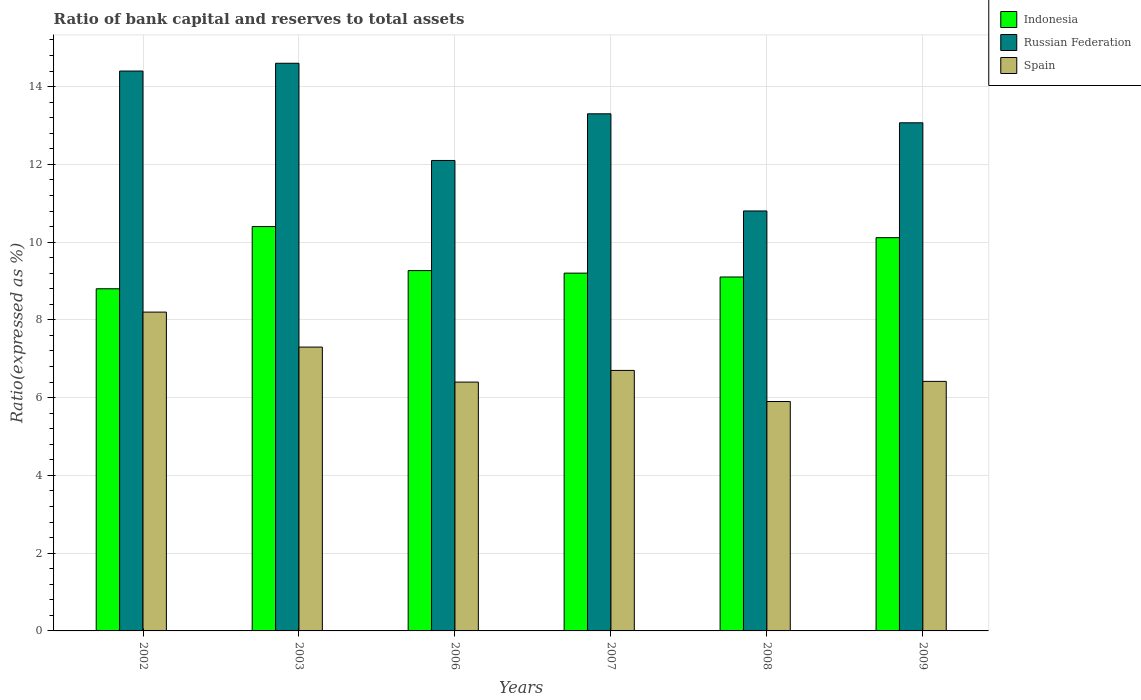How many different coloured bars are there?
Your answer should be compact. 3. How many groups of bars are there?
Provide a short and direct response. 6. How many bars are there on the 3rd tick from the right?
Make the answer very short. 3. What is the label of the 3rd group of bars from the left?
Provide a succinct answer. 2006. What is the ratio of bank capital and reserves to total assets in Indonesia in 2003?
Make the answer very short. 10.4. In which year was the ratio of bank capital and reserves to total assets in Spain maximum?
Ensure brevity in your answer.  2002. What is the total ratio of bank capital and reserves to total assets in Spain in the graph?
Keep it short and to the point. 40.92. What is the difference between the ratio of bank capital and reserves to total assets in Spain in 2002 and that in 2009?
Your response must be concise. 1.78. What is the difference between the ratio of bank capital and reserves to total assets in Spain in 2009 and the ratio of bank capital and reserves to total assets in Russian Federation in 2002?
Your answer should be very brief. -7.98. What is the average ratio of bank capital and reserves to total assets in Spain per year?
Make the answer very short. 6.82. In the year 2007, what is the difference between the ratio of bank capital and reserves to total assets in Indonesia and ratio of bank capital and reserves to total assets in Spain?
Ensure brevity in your answer.  2.5. What is the ratio of the ratio of bank capital and reserves to total assets in Spain in 2002 to that in 2007?
Make the answer very short. 1.22. What is the difference between the highest and the second highest ratio of bank capital and reserves to total assets in Russian Federation?
Your answer should be very brief. 0.2. What is the difference between the highest and the lowest ratio of bank capital and reserves to total assets in Spain?
Ensure brevity in your answer.  2.3. Is the sum of the ratio of bank capital and reserves to total assets in Indonesia in 2002 and 2009 greater than the maximum ratio of bank capital and reserves to total assets in Spain across all years?
Keep it short and to the point. Yes. What does the 3rd bar from the left in 2002 represents?
Your answer should be compact. Spain. What does the 1st bar from the right in 2008 represents?
Provide a short and direct response. Spain. Are all the bars in the graph horizontal?
Keep it short and to the point. No. How many years are there in the graph?
Provide a succinct answer. 6. Does the graph contain grids?
Ensure brevity in your answer.  Yes. How are the legend labels stacked?
Give a very brief answer. Vertical. What is the title of the graph?
Your response must be concise. Ratio of bank capital and reserves to total assets. What is the label or title of the Y-axis?
Keep it short and to the point. Ratio(expressed as %). What is the Ratio(expressed as %) in Indonesia in 2002?
Your response must be concise. 8.8. What is the Ratio(expressed as %) in Spain in 2002?
Your answer should be very brief. 8.2. What is the Ratio(expressed as %) in Indonesia in 2006?
Ensure brevity in your answer.  9.27. What is the Ratio(expressed as %) of Russian Federation in 2006?
Your response must be concise. 12.1. What is the Ratio(expressed as %) of Indonesia in 2007?
Give a very brief answer. 9.2. What is the Ratio(expressed as %) of Indonesia in 2008?
Provide a short and direct response. 9.1. What is the Ratio(expressed as %) in Russian Federation in 2008?
Provide a succinct answer. 10.8. What is the Ratio(expressed as %) in Spain in 2008?
Your answer should be compact. 5.9. What is the Ratio(expressed as %) of Indonesia in 2009?
Your response must be concise. 10.11. What is the Ratio(expressed as %) in Russian Federation in 2009?
Provide a succinct answer. 13.07. What is the Ratio(expressed as %) of Spain in 2009?
Keep it short and to the point. 6.42. Across all years, what is the maximum Ratio(expressed as %) in Russian Federation?
Make the answer very short. 14.6. Across all years, what is the minimum Ratio(expressed as %) in Indonesia?
Provide a succinct answer. 8.8. Across all years, what is the minimum Ratio(expressed as %) in Russian Federation?
Your answer should be very brief. 10.8. What is the total Ratio(expressed as %) of Indonesia in the graph?
Give a very brief answer. 56.89. What is the total Ratio(expressed as %) of Russian Federation in the graph?
Make the answer very short. 78.27. What is the total Ratio(expressed as %) in Spain in the graph?
Your answer should be compact. 40.92. What is the difference between the Ratio(expressed as %) of Indonesia in 2002 and that in 2003?
Your answer should be very brief. -1.6. What is the difference between the Ratio(expressed as %) in Russian Federation in 2002 and that in 2003?
Your response must be concise. -0.2. What is the difference between the Ratio(expressed as %) in Spain in 2002 and that in 2003?
Provide a succinct answer. 0.9. What is the difference between the Ratio(expressed as %) of Indonesia in 2002 and that in 2006?
Provide a succinct answer. -0.47. What is the difference between the Ratio(expressed as %) of Russian Federation in 2002 and that in 2006?
Ensure brevity in your answer.  2.3. What is the difference between the Ratio(expressed as %) in Spain in 2002 and that in 2006?
Ensure brevity in your answer.  1.8. What is the difference between the Ratio(expressed as %) of Indonesia in 2002 and that in 2007?
Keep it short and to the point. -0.4. What is the difference between the Ratio(expressed as %) in Russian Federation in 2002 and that in 2007?
Give a very brief answer. 1.1. What is the difference between the Ratio(expressed as %) in Indonesia in 2002 and that in 2008?
Your response must be concise. -0.3. What is the difference between the Ratio(expressed as %) in Russian Federation in 2002 and that in 2008?
Give a very brief answer. 3.6. What is the difference between the Ratio(expressed as %) of Spain in 2002 and that in 2008?
Provide a succinct answer. 2.3. What is the difference between the Ratio(expressed as %) in Indonesia in 2002 and that in 2009?
Your response must be concise. -1.31. What is the difference between the Ratio(expressed as %) of Russian Federation in 2002 and that in 2009?
Provide a succinct answer. 1.33. What is the difference between the Ratio(expressed as %) in Spain in 2002 and that in 2009?
Offer a terse response. 1.78. What is the difference between the Ratio(expressed as %) of Indonesia in 2003 and that in 2006?
Ensure brevity in your answer.  1.13. What is the difference between the Ratio(expressed as %) of Russian Federation in 2003 and that in 2006?
Provide a succinct answer. 2.5. What is the difference between the Ratio(expressed as %) of Spain in 2003 and that in 2006?
Provide a succinct answer. 0.9. What is the difference between the Ratio(expressed as %) of Indonesia in 2003 and that in 2007?
Provide a succinct answer. 1.2. What is the difference between the Ratio(expressed as %) of Indonesia in 2003 and that in 2008?
Make the answer very short. 1.3. What is the difference between the Ratio(expressed as %) of Russian Federation in 2003 and that in 2008?
Provide a short and direct response. 3.8. What is the difference between the Ratio(expressed as %) in Spain in 2003 and that in 2008?
Offer a terse response. 1.4. What is the difference between the Ratio(expressed as %) of Indonesia in 2003 and that in 2009?
Your response must be concise. 0.29. What is the difference between the Ratio(expressed as %) of Russian Federation in 2003 and that in 2009?
Provide a short and direct response. 1.53. What is the difference between the Ratio(expressed as %) in Spain in 2003 and that in 2009?
Offer a very short reply. 0.88. What is the difference between the Ratio(expressed as %) of Indonesia in 2006 and that in 2007?
Provide a short and direct response. 0.07. What is the difference between the Ratio(expressed as %) of Spain in 2006 and that in 2007?
Keep it short and to the point. -0.3. What is the difference between the Ratio(expressed as %) in Indonesia in 2006 and that in 2008?
Your answer should be very brief. 0.16. What is the difference between the Ratio(expressed as %) of Russian Federation in 2006 and that in 2008?
Make the answer very short. 1.3. What is the difference between the Ratio(expressed as %) of Spain in 2006 and that in 2008?
Offer a terse response. 0.5. What is the difference between the Ratio(expressed as %) of Indonesia in 2006 and that in 2009?
Give a very brief answer. -0.85. What is the difference between the Ratio(expressed as %) in Russian Federation in 2006 and that in 2009?
Make the answer very short. -0.97. What is the difference between the Ratio(expressed as %) in Spain in 2006 and that in 2009?
Your answer should be compact. -0.02. What is the difference between the Ratio(expressed as %) of Indonesia in 2007 and that in 2008?
Make the answer very short. 0.1. What is the difference between the Ratio(expressed as %) of Russian Federation in 2007 and that in 2008?
Make the answer very short. 2.5. What is the difference between the Ratio(expressed as %) of Spain in 2007 and that in 2008?
Make the answer very short. 0.8. What is the difference between the Ratio(expressed as %) of Indonesia in 2007 and that in 2009?
Provide a succinct answer. -0.91. What is the difference between the Ratio(expressed as %) in Russian Federation in 2007 and that in 2009?
Your answer should be compact. 0.23. What is the difference between the Ratio(expressed as %) of Spain in 2007 and that in 2009?
Offer a very short reply. 0.28. What is the difference between the Ratio(expressed as %) of Indonesia in 2008 and that in 2009?
Make the answer very short. -1.01. What is the difference between the Ratio(expressed as %) in Russian Federation in 2008 and that in 2009?
Ensure brevity in your answer.  -2.27. What is the difference between the Ratio(expressed as %) of Spain in 2008 and that in 2009?
Keep it short and to the point. -0.52. What is the difference between the Ratio(expressed as %) of Indonesia in 2002 and the Ratio(expressed as %) of Russian Federation in 2003?
Keep it short and to the point. -5.8. What is the difference between the Ratio(expressed as %) in Indonesia in 2002 and the Ratio(expressed as %) in Spain in 2003?
Offer a very short reply. 1.5. What is the difference between the Ratio(expressed as %) in Russian Federation in 2002 and the Ratio(expressed as %) in Spain in 2003?
Ensure brevity in your answer.  7.1. What is the difference between the Ratio(expressed as %) in Indonesia in 2002 and the Ratio(expressed as %) in Russian Federation in 2007?
Your response must be concise. -4.5. What is the difference between the Ratio(expressed as %) of Indonesia in 2002 and the Ratio(expressed as %) of Russian Federation in 2008?
Keep it short and to the point. -2. What is the difference between the Ratio(expressed as %) of Indonesia in 2002 and the Ratio(expressed as %) of Russian Federation in 2009?
Offer a very short reply. -4.27. What is the difference between the Ratio(expressed as %) in Indonesia in 2002 and the Ratio(expressed as %) in Spain in 2009?
Offer a terse response. 2.38. What is the difference between the Ratio(expressed as %) in Russian Federation in 2002 and the Ratio(expressed as %) in Spain in 2009?
Make the answer very short. 7.98. What is the difference between the Ratio(expressed as %) in Russian Federation in 2003 and the Ratio(expressed as %) in Spain in 2006?
Your answer should be compact. 8.2. What is the difference between the Ratio(expressed as %) of Indonesia in 2003 and the Ratio(expressed as %) of Russian Federation in 2007?
Your answer should be compact. -2.9. What is the difference between the Ratio(expressed as %) in Indonesia in 2003 and the Ratio(expressed as %) in Russian Federation in 2008?
Provide a short and direct response. -0.4. What is the difference between the Ratio(expressed as %) of Russian Federation in 2003 and the Ratio(expressed as %) of Spain in 2008?
Give a very brief answer. 8.7. What is the difference between the Ratio(expressed as %) of Indonesia in 2003 and the Ratio(expressed as %) of Russian Federation in 2009?
Make the answer very short. -2.67. What is the difference between the Ratio(expressed as %) in Indonesia in 2003 and the Ratio(expressed as %) in Spain in 2009?
Provide a short and direct response. 3.98. What is the difference between the Ratio(expressed as %) in Russian Federation in 2003 and the Ratio(expressed as %) in Spain in 2009?
Your answer should be compact. 8.18. What is the difference between the Ratio(expressed as %) of Indonesia in 2006 and the Ratio(expressed as %) of Russian Federation in 2007?
Ensure brevity in your answer.  -4.03. What is the difference between the Ratio(expressed as %) of Indonesia in 2006 and the Ratio(expressed as %) of Spain in 2007?
Offer a very short reply. 2.57. What is the difference between the Ratio(expressed as %) of Russian Federation in 2006 and the Ratio(expressed as %) of Spain in 2007?
Make the answer very short. 5.4. What is the difference between the Ratio(expressed as %) of Indonesia in 2006 and the Ratio(expressed as %) of Russian Federation in 2008?
Make the answer very short. -1.53. What is the difference between the Ratio(expressed as %) in Indonesia in 2006 and the Ratio(expressed as %) in Spain in 2008?
Ensure brevity in your answer.  3.37. What is the difference between the Ratio(expressed as %) in Russian Federation in 2006 and the Ratio(expressed as %) in Spain in 2008?
Keep it short and to the point. 6.2. What is the difference between the Ratio(expressed as %) in Indonesia in 2006 and the Ratio(expressed as %) in Russian Federation in 2009?
Ensure brevity in your answer.  -3.8. What is the difference between the Ratio(expressed as %) in Indonesia in 2006 and the Ratio(expressed as %) in Spain in 2009?
Your answer should be very brief. 2.85. What is the difference between the Ratio(expressed as %) in Russian Federation in 2006 and the Ratio(expressed as %) in Spain in 2009?
Make the answer very short. 5.68. What is the difference between the Ratio(expressed as %) in Indonesia in 2007 and the Ratio(expressed as %) in Russian Federation in 2008?
Your answer should be very brief. -1.6. What is the difference between the Ratio(expressed as %) of Indonesia in 2007 and the Ratio(expressed as %) of Spain in 2008?
Your answer should be compact. 3.3. What is the difference between the Ratio(expressed as %) of Russian Federation in 2007 and the Ratio(expressed as %) of Spain in 2008?
Your answer should be very brief. 7.4. What is the difference between the Ratio(expressed as %) in Indonesia in 2007 and the Ratio(expressed as %) in Russian Federation in 2009?
Give a very brief answer. -3.87. What is the difference between the Ratio(expressed as %) of Indonesia in 2007 and the Ratio(expressed as %) of Spain in 2009?
Your answer should be compact. 2.78. What is the difference between the Ratio(expressed as %) of Russian Federation in 2007 and the Ratio(expressed as %) of Spain in 2009?
Ensure brevity in your answer.  6.88. What is the difference between the Ratio(expressed as %) in Indonesia in 2008 and the Ratio(expressed as %) in Russian Federation in 2009?
Offer a very short reply. -3.97. What is the difference between the Ratio(expressed as %) in Indonesia in 2008 and the Ratio(expressed as %) in Spain in 2009?
Your response must be concise. 2.68. What is the difference between the Ratio(expressed as %) in Russian Federation in 2008 and the Ratio(expressed as %) in Spain in 2009?
Your response must be concise. 4.38. What is the average Ratio(expressed as %) of Indonesia per year?
Keep it short and to the point. 9.48. What is the average Ratio(expressed as %) of Russian Federation per year?
Make the answer very short. 13.04. What is the average Ratio(expressed as %) in Spain per year?
Your response must be concise. 6.82. In the year 2002, what is the difference between the Ratio(expressed as %) in Indonesia and Ratio(expressed as %) in Russian Federation?
Provide a short and direct response. -5.6. In the year 2002, what is the difference between the Ratio(expressed as %) of Indonesia and Ratio(expressed as %) of Spain?
Your response must be concise. 0.6. In the year 2006, what is the difference between the Ratio(expressed as %) in Indonesia and Ratio(expressed as %) in Russian Federation?
Offer a terse response. -2.83. In the year 2006, what is the difference between the Ratio(expressed as %) in Indonesia and Ratio(expressed as %) in Spain?
Give a very brief answer. 2.87. In the year 2006, what is the difference between the Ratio(expressed as %) in Russian Federation and Ratio(expressed as %) in Spain?
Provide a succinct answer. 5.7. In the year 2007, what is the difference between the Ratio(expressed as %) of Indonesia and Ratio(expressed as %) of Russian Federation?
Provide a short and direct response. -4.1. In the year 2007, what is the difference between the Ratio(expressed as %) of Indonesia and Ratio(expressed as %) of Spain?
Offer a terse response. 2.5. In the year 2008, what is the difference between the Ratio(expressed as %) in Indonesia and Ratio(expressed as %) in Russian Federation?
Your answer should be very brief. -1.7. In the year 2008, what is the difference between the Ratio(expressed as %) in Indonesia and Ratio(expressed as %) in Spain?
Make the answer very short. 3.2. In the year 2008, what is the difference between the Ratio(expressed as %) in Russian Federation and Ratio(expressed as %) in Spain?
Keep it short and to the point. 4.9. In the year 2009, what is the difference between the Ratio(expressed as %) in Indonesia and Ratio(expressed as %) in Russian Federation?
Provide a succinct answer. -2.95. In the year 2009, what is the difference between the Ratio(expressed as %) of Indonesia and Ratio(expressed as %) of Spain?
Offer a terse response. 3.7. In the year 2009, what is the difference between the Ratio(expressed as %) of Russian Federation and Ratio(expressed as %) of Spain?
Give a very brief answer. 6.65. What is the ratio of the Ratio(expressed as %) of Indonesia in 2002 to that in 2003?
Offer a very short reply. 0.85. What is the ratio of the Ratio(expressed as %) in Russian Federation in 2002 to that in 2003?
Give a very brief answer. 0.99. What is the ratio of the Ratio(expressed as %) in Spain in 2002 to that in 2003?
Your response must be concise. 1.12. What is the ratio of the Ratio(expressed as %) in Indonesia in 2002 to that in 2006?
Give a very brief answer. 0.95. What is the ratio of the Ratio(expressed as %) of Russian Federation in 2002 to that in 2006?
Your answer should be compact. 1.19. What is the ratio of the Ratio(expressed as %) of Spain in 2002 to that in 2006?
Offer a very short reply. 1.28. What is the ratio of the Ratio(expressed as %) in Indonesia in 2002 to that in 2007?
Provide a short and direct response. 0.96. What is the ratio of the Ratio(expressed as %) in Russian Federation in 2002 to that in 2007?
Make the answer very short. 1.08. What is the ratio of the Ratio(expressed as %) of Spain in 2002 to that in 2007?
Provide a succinct answer. 1.22. What is the ratio of the Ratio(expressed as %) in Indonesia in 2002 to that in 2008?
Ensure brevity in your answer.  0.97. What is the ratio of the Ratio(expressed as %) of Russian Federation in 2002 to that in 2008?
Provide a short and direct response. 1.33. What is the ratio of the Ratio(expressed as %) in Spain in 2002 to that in 2008?
Ensure brevity in your answer.  1.39. What is the ratio of the Ratio(expressed as %) in Indonesia in 2002 to that in 2009?
Keep it short and to the point. 0.87. What is the ratio of the Ratio(expressed as %) of Russian Federation in 2002 to that in 2009?
Make the answer very short. 1.1. What is the ratio of the Ratio(expressed as %) in Spain in 2002 to that in 2009?
Provide a short and direct response. 1.28. What is the ratio of the Ratio(expressed as %) of Indonesia in 2003 to that in 2006?
Your response must be concise. 1.12. What is the ratio of the Ratio(expressed as %) in Russian Federation in 2003 to that in 2006?
Offer a very short reply. 1.21. What is the ratio of the Ratio(expressed as %) of Spain in 2003 to that in 2006?
Provide a short and direct response. 1.14. What is the ratio of the Ratio(expressed as %) of Indonesia in 2003 to that in 2007?
Provide a short and direct response. 1.13. What is the ratio of the Ratio(expressed as %) in Russian Federation in 2003 to that in 2007?
Provide a short and direct response. 1.1. What is the ratio of the Ratio(expressed as %) of Spain in 2003 to that in 2007?
Offer a terse response. 1.09. What is the ratio of the Ratio(expressed as %) in Indonesia in 2003 to that in 2008?
Provide a succinct answer. 1.14. What is the ratio of the Ratio(expressed as %) of Russian Federation in 2003 to that in 2008?
Your answer should be very brief. 1.35. What is the ratio of the Ratio(expressed as %) in Spain in 2003 to that in 2008?
Keep it short and to the point. 1.24. What is the ratio of the Ratio(expressed as %) of Indonesia in 2003 to that in 2009?
Give a very brief answer. 1.03. What is the ratio of the Ratio(expressed as %) in Russian Federation in 2003 to that in 2009?
Give a very brief answer. 1.12. What is the ratio of the Ratio(expressed as %) in Spain in 2003 to that in 2009?
Make the answer very short. 1.14. What is the ratio of the Ratio(expressed as %) in Indonesia in 2006 to that in 2007?
Ensure brevity in your answer.  1.01. What is the ratio of the Ratio(expressed as %) of Russian Federation in 2006 to that in 2007?
Your answer should be very brief. 0.91. What is the ratio of the Ratio(expressed as %) in Spain in 2006 to that in 2007?
Offer a terse response. 0.96. What is the ratio of the Ratio(expressed as %) in Indonesia in 2006 to that in 2008?
Your response must be concise. 1.02. What is the ratio of the Ratio(expressed as %) of Russian Federation in 2006 to that in 2008?
Give a very brief answer. 1.12. What is the ratio of the Ratio(expressed as %) of Spain in 2006 to that in 2008?
Ensure brevity in your answer.  1.08. What is the ratio of the Ratio(expressed as %) of Indonesia in 2006 to that in 2009?
Give a very brief answer. 0.92. What is the ratio of the Ratio(expressed as %) in Russian Federation in 2006 to that in 2009?
Your answer should be compact. 0.93. What is the ratio of the Ratio(expressed as %) in Spain in 2006 to that in 2009?
Provide a succinct answer. 1. What is the ratio of the Ratio(expressed as %) of Indonesia in 2007 to that in 2008?
Your answer should be compact. 1.01. What is the ratio of the Ratio(expressed as %) of Russian Federation in 2007 to that in 2008?
Your answer should be compact. 1.23. What is the ratio of the Ratio(expressed as %) of Spain in 2007 to that in 2008?
Your response must be concise. 1.14. What is the ratio of the Ratio(expressed as %) of Indonesia in 2007 to that in 2009?
Provide a short and direct response. 0.91. What is the ratio of the Ratio(expressed as %) in Russian Federation in 2007 to that in 2009?
Provide a short and direct response. 1.02. What is the ratio of the Ratio(expressed as %) of Spain in 2007 to that in 2009?
Provide a succinct answer. 1.04. What is the ratio of the Ratio(expressed as %) in Indonesia in 2008 to that in 2009?
Make the answer very short. 0.9. What is the ratio of the Ratio(expressed as %) of Russian Federation in 2008 to that in 2009?
Your answer should be compact. 0.83. What is the ratio of the Ratio(expressed as %) in Spain in 2008 to that in 2009?
Provide a short and direct response. 0.92. What is the difference between the highest and the second highest Ratio(expressed as %) of Indonesia?
Make the answer very short. 0.29. What is the difference between the highest and the second highest Ratio(expressed as %) in Russian Federation?
Your answer should be compact. 0.2. What is the difference between the highest and the second highest Ratio(expressed as %) in Spain?
Make the answer very short. 0.9. What is the difference between the highest and the lowest Ratio(expressed as %) in Indonesia?
Your response must be concise. 1.6. What is the difference between the highest and the lowest Ratio(expressed as %) in Russian Federation?
Keep it short and to the point. 3.8. What is the difference between the highest and the lowest Ratio(expressed as %) in Spain?
Offer a very short reply. 2.3. 